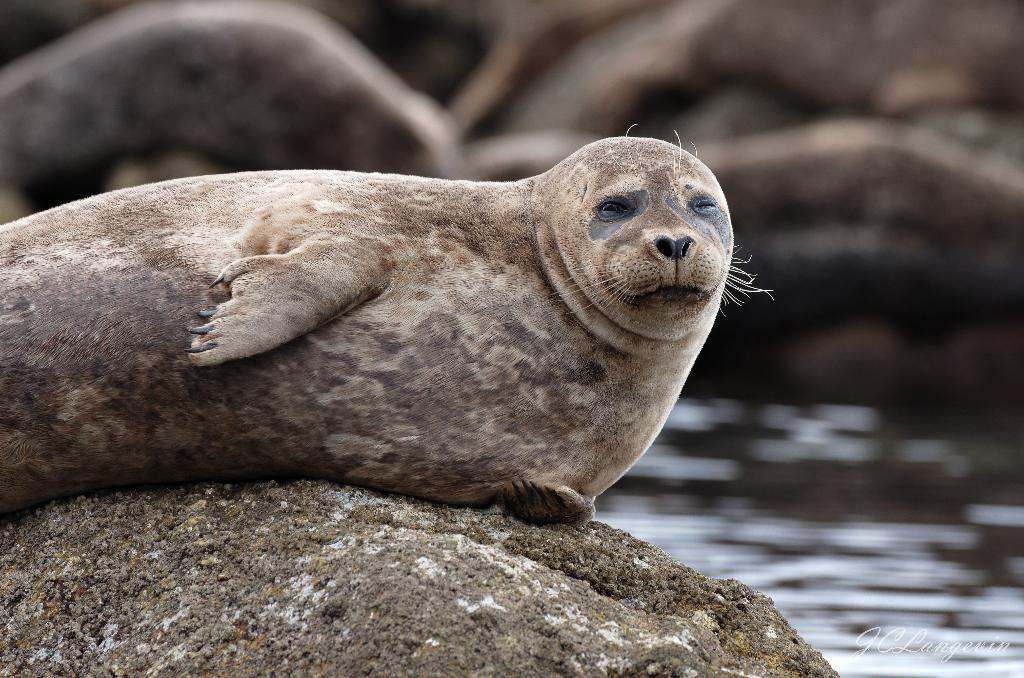What animals are present in the image? There are seals in the image. Can you describe the position of one of the seals? There is a seal on a rock in the foreground. What type of environment is depicted in the image? There is water visible at the bottom of the image, suggesting a coastal or marine setting. Is there any text present in the image? Yes, there is text at the bottom right of the image. How many women are present in the image? There are no women present in the image; it features seals in a marine setting. Can you tell me how many sheep are visible in the image? There are no sheep present in the image; it features seals in a marine setting. 